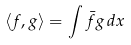Convert formula to latex. <formula><loc_0><loc_0><loc_500><loc_500>\langle f , g \rangle = \int \bar { f } g \, d x</formula> 